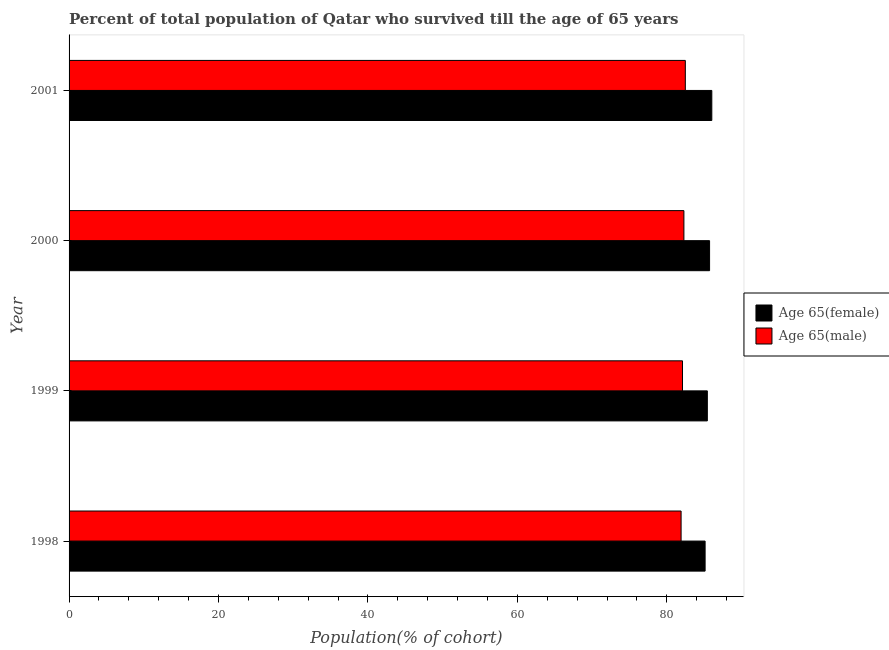Are the number of bars on each tick of the Y-axis equal?
Provide a short and direct response. Yes. How many bars are there on the 4th tick from the bottom?
Make the answer very short. 2. In how many cases, is the number of bars for a given year not equal to the number of legend labels?
Provide a short and direct response. 0. What is the percentage of female population who survived till age of 65 in 2001?
Your response must be concise. 86.02. Across all years, what is the maximum percentage of female population who survived till age of 65?
Make the answer very short. 86.02. Across all years, what is the minimum percentage of female population who survived till age of 65?
Make the answer very short. 85.12. In which year was the percentage of female population who survived till age of 65 maximum?
Give a very brief answer. 2001. What is the total percentage of male population who survived till age of 65 in the graph?
Your answer should be compact. 328.75. What is the difference between the percentage of female population who survived till age of 65 in 1998 and that in 1999?
Offer a terse response. -0.3. What is the difference between the percentage of female population who survived till age of 65 in 1999 and the percentage of male population who survived till age of 65 in 2000?
Your answer should be very brief. 3.14. What is the average percentage of female population who survived till age of 65 per year?
Your answer should be very brief. 85.57. In the year 1999, what is the difference between the percentage of male population who survived till age of 65 and percentage of female population who survived till age of 65?
Ensure brevity in your answer.  -3.32. What is the ratio of the percentage of male population who survived till age of 65 in 1999 to that in 2000?
Offer a terse response. 1. Is the difference between the percentage of female population who survived till age of 65 in 1998 and 2001 greater than the difference between the percentage of male population who survived till age of 65 in 1998 and 2001?
Keep it short and to the point. No. What is the difference between the highest and the second highest percentage of male population who survived till age of 65?
Make the answer very short. 0.19. What is the difference between the highest and the lowest percentage of male population who survived till age of 65?
Ensure brevity in your answer.  0.57. In how many years, is the percentage of male population who survived till age of 65 greater than the average percentage of male population who survived till age of 65 taken over all years?
Offer a very short reply. 2. Is the sum of the percentage of male population who survived till age of 65 in 1998 and 2001 greater than the maximum percentage of female population who survived till age of 65 across all years?
Keep it short and to the point. Yes. What does the 1st bar from the top in 1999 represents?
Your answer should be compact. Age 65(male). What does the 2nd bar from the bottom in 1999 represents?
Your answer should be compact. Age 65(male). Are all the bars in the graph horizontal?
Your answer should be compact. Yes. How many years are there in the graph?
Give a very brief answer. 4. What is the difference between two consecutive major ticks on the X-axis?
Make the answer very short. 20. Are the values on the major ticks of X-axis written in scientific E-notation?
Offer a very short reply. No. Does the graph contain grids?
Provide a succinct answer. No. How many legend labels are there?
Offer a very short reply. 2. What is the title of the graph?
Provide a succinct answer. Percent of total population of Qatar who survived till the age of 65 years. What is the label or title of the X-axis?
Provide a short and direct response. Population(% of cohort). What is the Population(% of cohort) of Age 65(female) in 1998?
Your answer should be compact. 85.12. What is the Population(% of cohort) in Age 65(male) in 1998?
Provide a short and direct response. 81.9. What is the Population(% of cohort) in Age 65(female) in 1999?
Your answer should be compact. 85.42. What is the Population(% of cohort) in Age 65(male) in 1999?
Make the answer very short. 82.09. What is the Population(% of cohort) of Age 65(female) in 2000?
Keep it short and to the point. 85.72. What is the Population(% of cohort) of Age 65(male) in 2000?
Your answer should be compact. 82.28. What is the Population(% of cohort) in Age 65(female) in 2001?
Keep it short and to the point. 86.02. What is the Population(% of cohort) in Age 65(male) in 2001?
Ensure brevity in your answer.  82.47. Across all years, what is the maximum Population(% of cohort) in Age 65(female)?
Your answer should be very brief. 86.02. Across all years, what is the maximum Population(% of cohort) of Age 65(male)?
Ensure brevity in your answer.  82.47. Across all years, what is the minimum Population(% of cohort) of Age 65(female)?
Your answer should be compact. 85.12. Across all years, what is the minimum Population(% of cohort) of Age 65(male)?
Keep it short and to the point. 81.9. What is the total Population(% of cohort) in Age 65(female) in the graph?
Ensure brevity in your answer.  342.27. What is the total Population(% of cohort) in Age 65(male) in the graph?
Offer a terse response. 328.75. What is the difference between the Population(% of cohort) of Age 65(female) in 1998 and that in 1999?
Your answer should be compact. -0.3. What is the difference between the Population(% of cohort) in Age 65(male) in 1998 and that in 1999?
Provide a succinct answer. -0.19. What is the difference between the Population(% of cohort) of Age 65(female) in 1998 and that in 2000?
Give a very brief answer. -0.6. What is the difference between the Population(% of cohort) of Age 65(male) in 1998 and that in 2000?
Your answer should be very brief. -0.38. What is the difference between the Population(% of cohort) in Age 65(female) in 1998 and that in 2001?
Keep it short and to the point. -0.9. What is the difference between the Population(% of cohort) in Age 65(male) in 1998 and that in 2001?
Your response must be concise. -0.57. What is the difference between the Population(% of cohort) in Age 65(female) in 1999 and that in 2000?
Offer a terse response. -0.3. What is the difference between the Population(% of cohort) of Age 65(male) in 1999 and that in 2000?
Provide a short and direct response. -0.19. What is the difference between the Population(% of cohort) of Age 65(female) in 1999 and that in 2001?
Your response must be concise. -0.6. What is the difference between the Population(% of cohort) in Age 65(male) in 1999 and that in 2001?
Your answer should be very brief. -0.38. What is the difference between the Population(% of cohort) of Age 65(female) in 2000 and that in 2001?
Provide a short and direct response. -0.3. What is the difference between the Population(% of cohort) of Age 65(male) in 2000 and that in 2001?
Make the answer very short. -0.19. What is the difference between the Population(% of cohort) of Age 65(female) in 1998 and the Population(% of cohort) of Age 65(male) in 1999?
Your response must be concise. 3.03. What is the difference between the Population(% of cohort) in Age 65(female) in 1998 and the Population(% of cohort) in Age 65(male) in 2000?
Offer a terse response. 2.84. What is the difference between the Population(% of cohort) of Age 65(female) in 1998 and the Population(% of cohort) of Age 65(male) in 2001?
Provide a short and direct response. 2.65. What is the difference between the Population(% of cohort) in Age 65(female) in 1999 and the Population(% of cohort) in Age 65(male) in 2000?
Give a very brief answer. 3.14. What is the difference between the Population(% of cohort) of Age 65(female) in 1999 and the Population(% of cohort) of Age 65(male) in 2001?
Provide a short and direct response. 2.95. What is the difference between the Population(% of cohort) in Age 65(female) in 2000 and the Population(% of cohort) in Age 65(male) in 2001?
Offer a very short reply. 3.25. What is the average Population(% of cohort) of Age 65(female) per year?
Keep it short and to the point. 85.57. What is the average Population(% of cohort) of Age 65(male) per year?
Offer a terse response. 82.19. In the year 1998, what is the difference between the Population(% of cohort) of Age 65(female) and Population(% of cohort) of Age 65(male)?
Your response must be concise. 3.21. In the year 1999, what is the difference between the Population(% of cohort) of Age 65(female) and Population(% of cohort) of Age 65(male)?
Your answer should be very brief. 3.32. In the year 2000, what is the difference between the Population(% of cohort) of Age 65(female) and Population(% of cohort) of Age 65(male)?
Make the answer very short. 3.43. In the year 2001, what is the difference between the Population(% of cohort) of Age 65(female) and Population(% of cohort) of Age 65(male)?
Your answer should be very brief. 3.54. What is the ratio of the Population(% of cohort) in Age 65(female) in 1998 to that in 1999?
Offer a terse response. 1. What is the ratio of the Population(% of cohort) in Age 65(male) in 1998 to that in 1999?
Offer a terse response. 1. What is the ratio of the Population(% of cohort) of Age 65(male) in 1998 to that in 2000?
Offer a very short reply. 1. What is the ratio of the Population(% of cohort) of Age 65(female) in 1999 to that in 2000?
Ensure brevity in your answer.  1. What is the ratio of the Population(% of cohort) in Age 65(male) in 1999 to that in 2001?
Your answer should be compact. 1. What is the difference between the highest and the second highest Population(% of cohort) of Age 65(female)?
Ensure brevity in your answer.  0.3. What is the difference between the highest and the second highest Population(% of cohort) of Age 65(male)?
Offer a very short reply. 0.19. What is the difference between the highest and the lowest Population(% of cohort) in Age 65(female)?
Give a very brief answer. 0.9. What is the difference between the highest and the lowest Population(% of cohort) of Age 65(male)?
Provide a short and direct response. 0.57. 